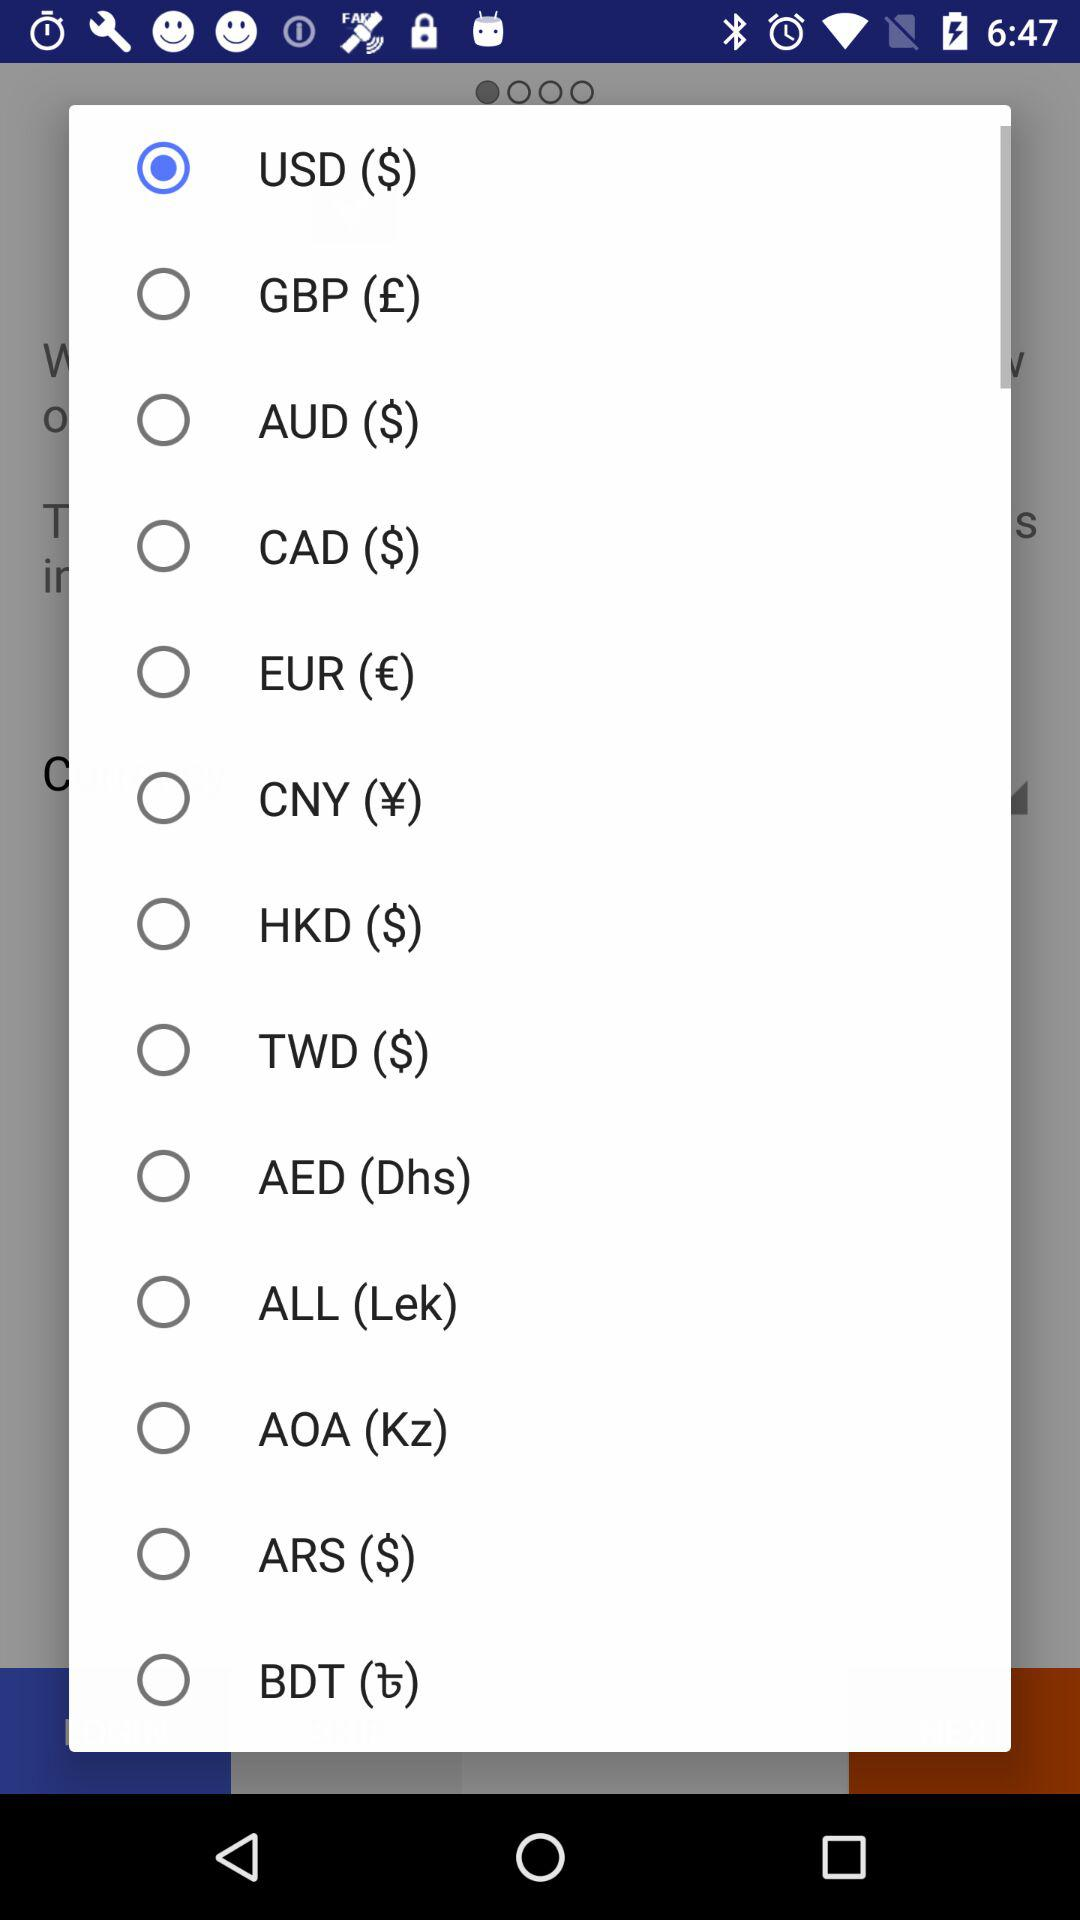Which radio button is selected? The selected radio button is "USD ($)". 